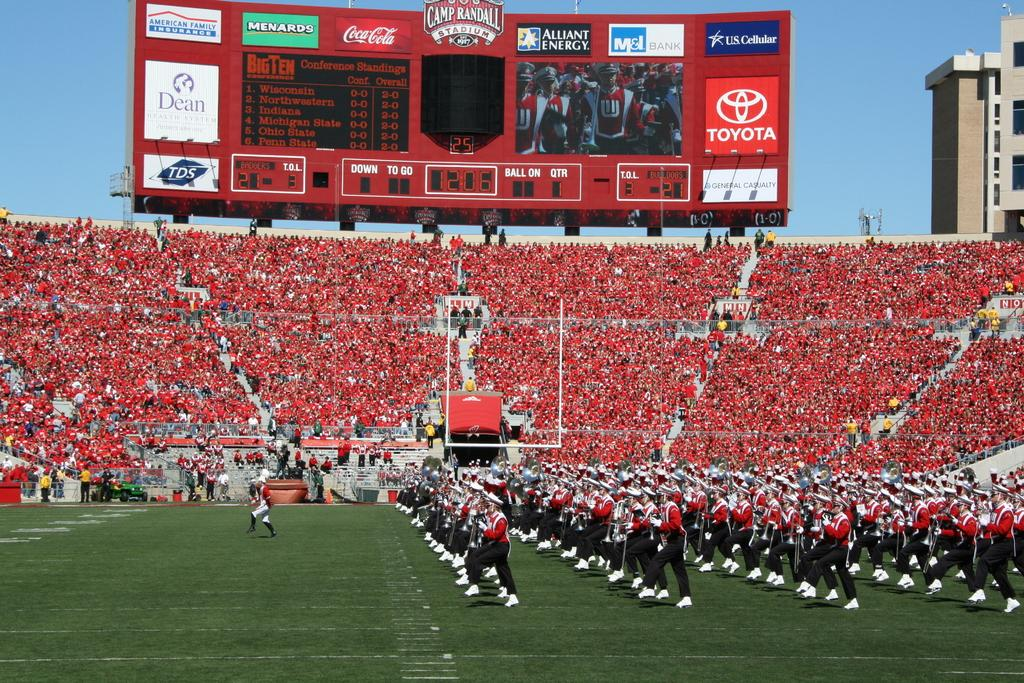<image>
Create a compact narrative representing the image presented. A marching band is performing on a football field sponsored by Toyota, Coca Cola, and several other companies with their names on the scoreboard. 